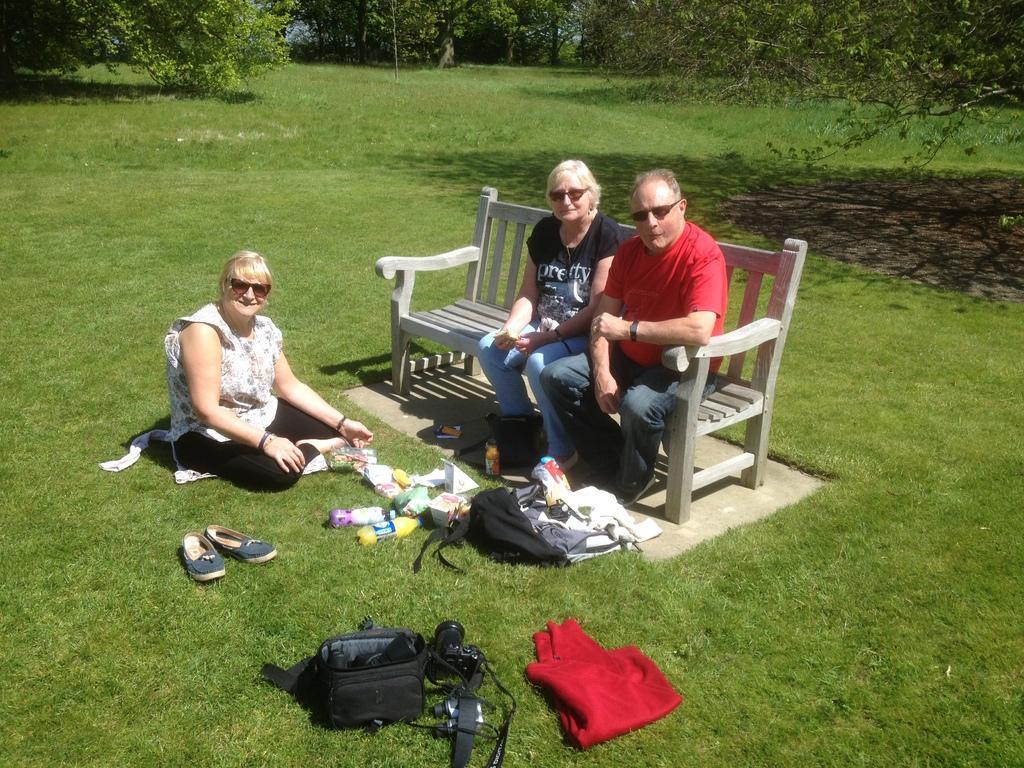Could you give a brief overview of what you see in this image? In this picture there are two persons sitting on a bench and there is another woman sitting on a greenery ground in front of them and there are few other objects beside them and there are trees in the background. 